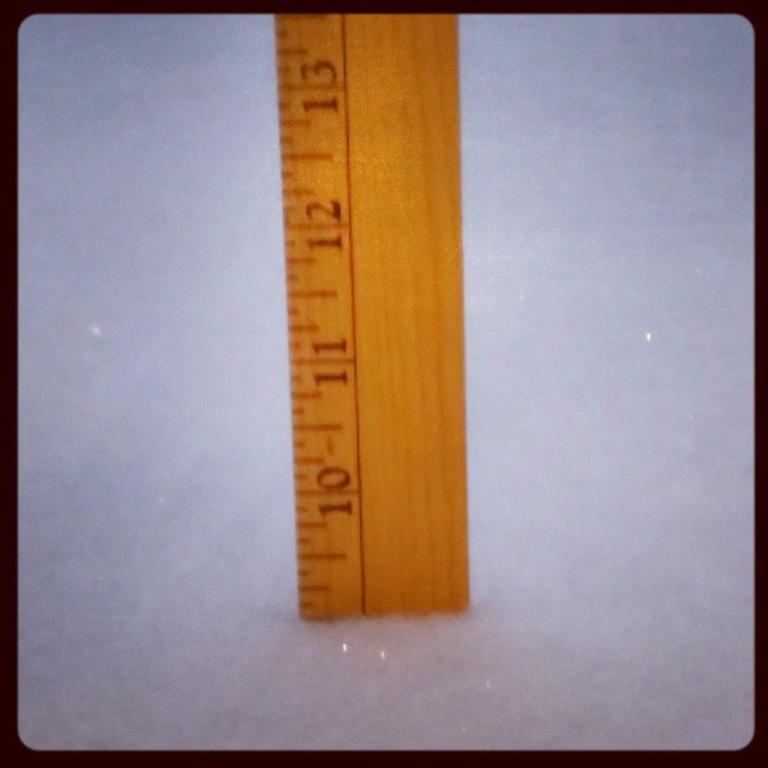<image>
Write a terse but informative summary of the picture. A ruler showing that there is snow piled up to nearly the 10 inch mark. 